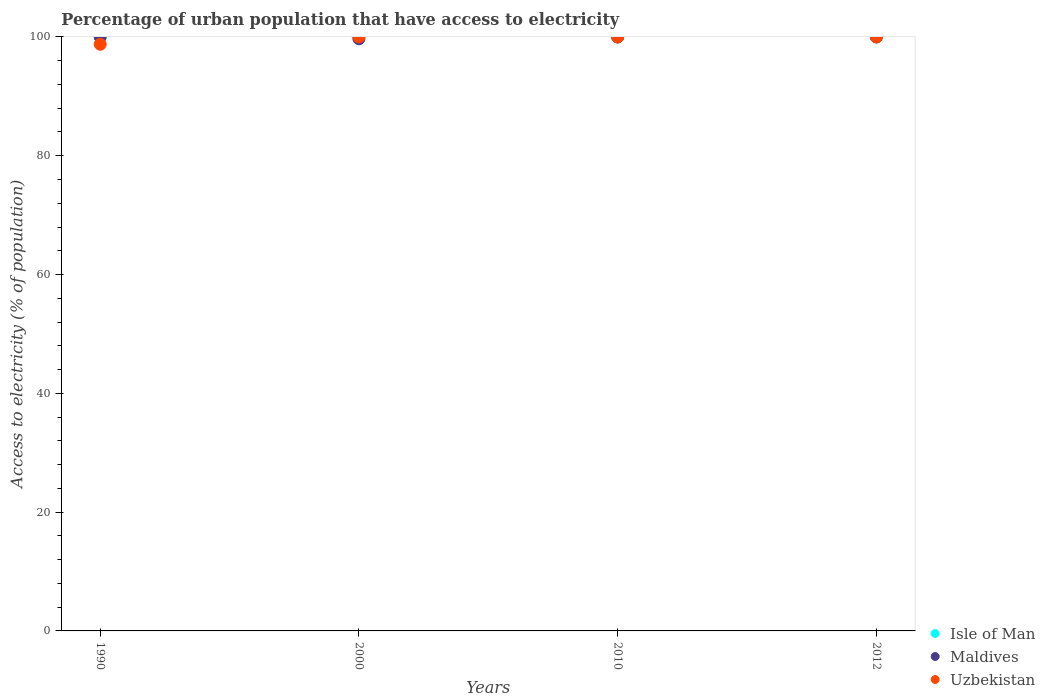How many different coloured dotlines are there?
Your answer should be very brief. 3. Is the number of dotlines equal to the number of legend labels?
Provide a succinct answer. Yes. Across all years, what is the minimum percentage of urban population that have access to electricity in Maldives?
Ensure brevity in your answer.  99.68. What is the total percentage of urban population that have access to electricity in Isle of Man in the graph?
Provide a short and direct response. 400. What is the difference between the percentage of urban population that have access to electricity in Maldives in 2010 and the percentage of urban population that have access to electricity in Uzbekistan in 2012?
Make the answer very short. 0. What is the average percentage of urban population that have access to electricity in Uzbekistan per year?
Your answer should be very brief. 99.69. In the year 1990, what is the difference between the percentage of urban population that have access to electricity in Maldives and percentage of urban population that have access to electricity in Uzbekistan?
Give a very brief answer. 1.23. What is the ratio of the percentage of urban population that have access to electricity in Isle of Man in 2000 to that in 2010?
Give a very brief answer. 1. Is the percentage of urban population that have access to electricity in Uzbekistan in 1990 less than that in 2012?
Your answer should be compact. Yes. Is the difference between the percentage of urban population that have access to electricity in Maldives in 1990 and 2010 greater than the difference between the percentage of urban population that have access to electricity in Uzbekistan in 1990 and 2010?
Your answer should be compact. Yes. What is the difference between the highest and the second highest percentage of urban population that have access to electricity in Isle of Man?
Offer a very short reply. 0. What is the difference between the highest and the lowest percentage of urban population that have access to electricity in Uzbekistan?
Offer a terse response. 1.23. Is the sum of the percentage of urban population that have access to electricity in Isle of Man in 1990 and 2010 greater than the maximum percentage of urban population that have access to electricity in Maldives across all years?
Keep it short and to the point. Yes. Is it the case that in every year, the sum of the percentage of urban population that have access to electricity in Isle of Man and percentage of urban population that have access to electricity in Uzbekistan  is greater than the percentage of urban population that have access to electricity in Maldives?
Ensure brevity in your answer.  Yes. Does the graph contain any zero values?
Your response must be concise. No. How many legend labels are there?
Your response must be concise. 3. How are the legend labels stacked?
Provide a short and direct response. Vertical. What is the title of the graph?
Make the answer very short. Percentage of urban population that have access to electricity. What is the label or title of the Y-axis?
Provide a short and direct response. Access to electricity (% of population). What is the Access to electricity (% of population) of Isle of Man in 1990?
Provide a short and direct response. 100. What is the Access to electricity (% of population) of Maldives in 1990?
Make the answer very short. 100. What is the Access to electricity (% of population) in Uzbekistan in 1990?
Your response must be concise. 98.77. What is the Access to electricity (% of population) of Isle of Man in 2000?
Ensure brevity in your answer.  100. What is the Access to electricity (% of population) in Maldives in 2000?
Keep it short and to the point. 99.68. What is the Access to electricity (% of population) of Isle of Man in 2010?
Provide a succinct answer. 100. What is the Access to electricity (% of population) in Maldives in 2010?
Your answer should be very brief. 100. What is the Access to electricity (% of population) in Uzbekistan in 2010?
Your answer should be very brief. 100. What is the Access to electricity (% of population) in Maldives in 2012?
Offer a very short reply. 100. What is the Access to electricity (% of population) in Uzbekistan in 2012?
Your answer should be compact. 100. Across all years, what is the maximum Access to electricity (% of population) in Isle of Man?
Provide a succinct answer. 100. Across all years, what is the maximum Access to electricity (% of population) in Maldives?
Keep it short and to the point. 100. Across all years, what is the maximum Access to electricity (% of population) in Uzbekistan?
Ensure brevity in your answer.  100. Across all years, what is the minimum Access to electricity (% of population) in Isle of Man?
Keep it short and to the point. 100. Across all years, what is the minimum Access to electricity (% of population) in Maldives?
Make the answer very short. 99.68. Across all years, what is the minimum Access to electricity (% of population) of Uzbekistan?
Ensure brevity in your answer.  98.77. What is the total Access to electricity (% of population) in Isle of Man in the graph?
Your answer should be very brief. 400. What is the total Access to electricity (% of population) in Maldives in the graph?
Your answer should be very brief. 399.68. What is the total Access to electricity (% of population) of Uzbekistan in the graph?
Your response must be concise. 398.77. What is the difference between the Access to electricity (% of population) of Isle of Man in 1990 and that in 2000?
Make the answer very short. 0. What is the difference between the Access to electricity (% of population) of Maldives in 1990 and that in 2000?
Your answer should be compact. 0.32. What is the difference between the Access to electricity (% of population) of Uzbekistan in 1990 and that in 2000?
Provide a short and direct response. -1.23. What is the difference between the Access to electricity (% of population) in Isle of Man in 1990 and that in 2010?
Your answer should be compact. 0. What is the difference between the Access to electricity (% of population) of Maldives in 1990 and that in 2010?
Your answer should be compact. 0. What is the difference between the Access to electricity (% of population) of Uzbekistan in 1990 and that in 2010?
Provide a succinct answer. -1.23. What is the difference between the Access to electricity (% of population) of Maldives in 1990 and that in 2012?
Provide a succinct answer. 0. What is the difference between the Access to electricity (% of population) of Uzbekistan in 1990 and that in 2012?
Ensure brevity in your answer.  -1.23. What is the difference between the Access to electricity (% of population) of Maldives in 2000 and that in 2010?
Ensure brevity in your answer.  -0.32. What is the difference between the Access to electricity (% of population) in Uzbekistan in 2000 and that in 2010?
Ensure brevity in your answer.  0. What is the difference between the Access to electricity (% of population) of Maldives in 2000 and that in 2012?
Provide a succinct answer. -0.32. What is the difference between the Access to electricity (% of population) in Uzbekistan in 2000 and that in 2012?
Your answer should be compact. 0. What is the difference between the Access to electricity (% of population) in Maldives in 2010 and that in 2012?
Ensure brevity in your answer.  0. What is the difference between the Access to electricity (% of population) in Isle of Man in 1990 and the Access to electricity (% of population) in Maldives in 2000?
Give a very brief answer. 0.32. What is the difference between the Access to electricity (% of population) in Isle of Man in 1990 and the Access to electricity (% of population) in Uzbekistan in 2000?
Offer a terse response. 0. What is the difference between the Access to electricity (% of population) of Isle of Man in 1990 and the Access to electricity (% of population) of Maldives in 2010?
Make the answer very short. 0. What is the difference between the Access to electricity (% of population) of Maldives in 1990 and the Access to electricity (% of population) of Uzbekistan in 2012?
Offer a terse response. 0. What is the difference between the Access to electricity (% of population) of Isle of Man in 2000 and the Access to electricity (% of population) of Maldives in 2010?
Provide a short and direct response. 0. What is the difference between the Access to electricity (% of population) of Isle of Man in 2000 and the Access to electricity (% of population) of Uzbekistan in 2010?
Offer a terse response. 0. What is the difference between the Access to electricity (% of population) of Maldives in 2000 and the Access to electricity (% of population) of Uzbekistan in 2010?
Provide a short and direct response. -0.32. What is the difference between the Access to electricity (% of population) in Isle of Man in 2000 and the Access to electricity (% of population) in Maldives in 2012?
Provide a short and direct response. 0. What is the difference between the Access to electricity (% of population) in Maldives in 2000 and the Access to electricity (% of population) in Uzbekistan in 2012?
Provide a short and direct response. -0.32. What is the difference between the Access to electricity (% of population) in Maldives in 2010 and the Access to electricity (% of population) in Uzbekistan in 2012?
Give a very brief answer. 0. What is the average Access to electricity (% of population) of Isle of Man per year?
Your answer should be very brief. 100. What is the average Access to electricity (% of population) of Maldives per year?
Your answer should be very brief. 99.92. What is the average Access to electricity (% of population) in Uzbekistan per year?
Offer a terse response. 99.69. In the year 1990, what is the difference between the Access to electricity (% of population) of Isle of Man and Access to electricity (% of population) of Maldives?
Offer a very short reply. 0. In the year 1990, what is the difference between the Access to electricity (% of population) in Isle of Man and Access to electricity (% of population) in Uzbekistan?
Make the answer very short. 1.23. In the year 1990, what is the difference between the Access to electricity (% of population) of Maldives and Access to electricity (% of population) of Uzbekistan?
Provide a succinct answer. 1.23. In the year 2000, what is the difference between the Access to electricity (% of population) of Isle of Man and Access to electricity (% of population) of Maldives?
Give a very brief answer. 0.32. In the year 2000, what is the difference between the Access to electricity (% of population) in Isle of Man and Access to electricity (% of population) in Uzbekistan?
Ensure brevity in your answer.  0. In the year 2000, what is the difference between the Access to electricity (% of population) in Maldives and Access to electricity (% of population) in Uzbekistan?
Keep it short and to the point. -0.32. In the year 2010, what is the difference between the Access to electricity (% of population) in Isle of Man and Access to electricity (% of population) in Maldives?
Your answer should be compact. 0. In the year 2010, what is the difference between the Access to electricity (% of population) of Isle of Man and Access to electricity (% of population) of Uzbekistan?
Your response must be concise. 0. In the year 2012, what is the difference between the Access to electricity (% of population) of Isle of Man and Access to electricity (% of population) of Uzbekistan?
Give a very brief answer. 0. What is the ratio of the Access to electricity (% of population) in Uzbekistan in 1990 to that in 2000?
Offer a very short reply. 0.99. What is the ratio of the Access to electricity (% of population) in Isle of Man in 1990 to that in 2010?
Make the answer very short. 1. What is the ratio of the Access to electricity (% of population) in Isle of Man in 1990 to that in 2012?
Keep it short and to the point. 1. What is the ratio of the Access to electricity (% of population) in Maldives in 1990 to that in 2012?
Give a very brief answer. 1. What is the ratio of the Access to electricity (% of population) of Uzbekistan in 1990 to that in 2012?
Give a very brief answer. 0.99. What is the ratio of the Access to electricity (% of population) in Maldives in 2000 to that in 2010?
Your answer should be compact. 1. What is the ratio of the Access to electricity (% of population) of Isle of Man in 2000 to that in 2012?
Offer a very short reply. 1. What is the ratio of the Access to electricity (% of population) in Uzbekistan in 2000 to that in 2012?
Your answer should be compact. 1. What is the ratio of the Access to electricity (% of population) in Isle of Man in 2010 to that in 2012?
Offer a terse response. 1. What is the ratio of the Access to electricity (% of population) of Maldives in 2010 to that in 2012?
Your response must be concise. 1. What is the ratio of the Access to electricity (% of population) of Uzbekistan in 2010 to that in 2012?
Provide a succinct answer. 1. What is the difference between the highest and the second highest Access to electricity (% of population) in Isle of Man?
Provide a succinct answer. 0. What is the difference between the highest and the second highest Access to electricity (% of population) of Uzbekistan?
Offer a very short reply. 0. What is the difference between the highest and the lowest Access to electricity (% of population) in Isle of Man?
Your answer should be compact. 0. What is the difference between the highest and the lowest Access to electricity (% of population) in Maldives?
Provide a short and direct response. 0.32. What is the difference between the highest and the lowest Access to electricity (% of population) of Uzbekistan?
Offer a very short reply. 1.23. 